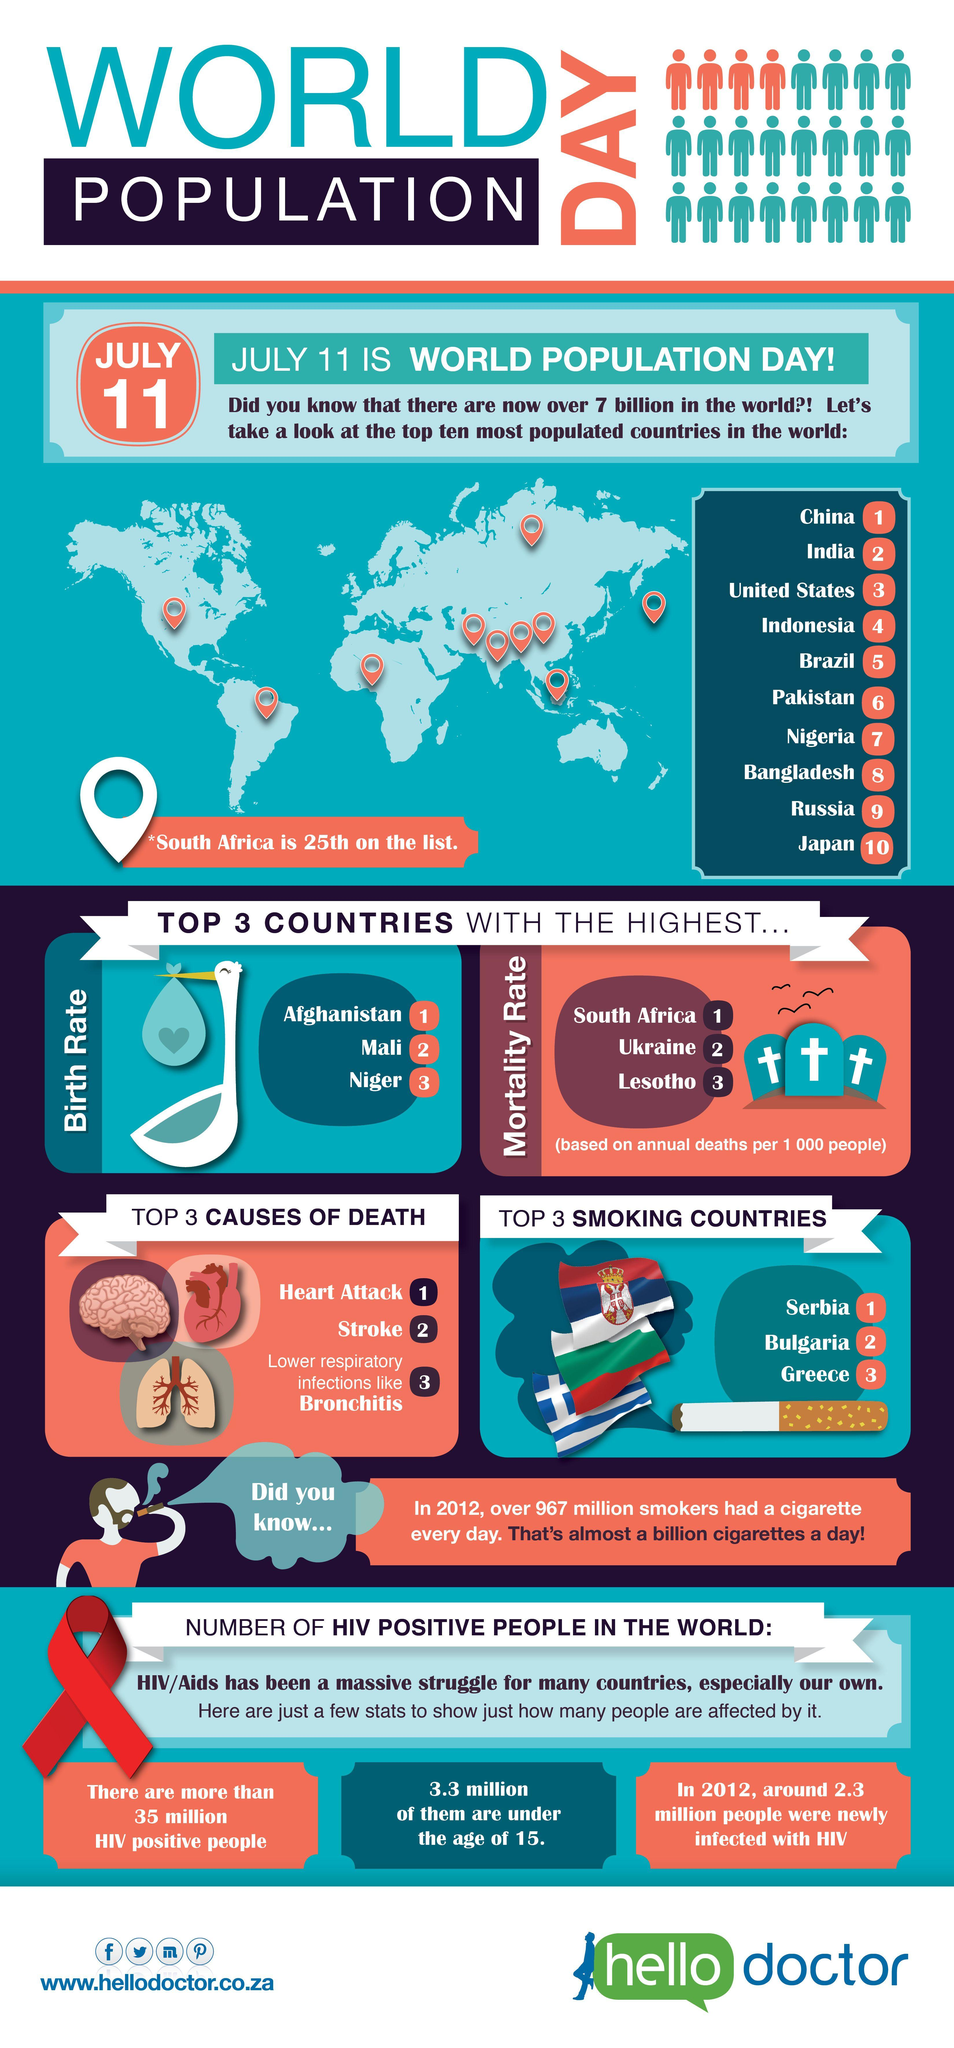List a handful of essential elements in this visual. The total number of countries with the highest birth rate and mortality rate, taken together, is 6. 